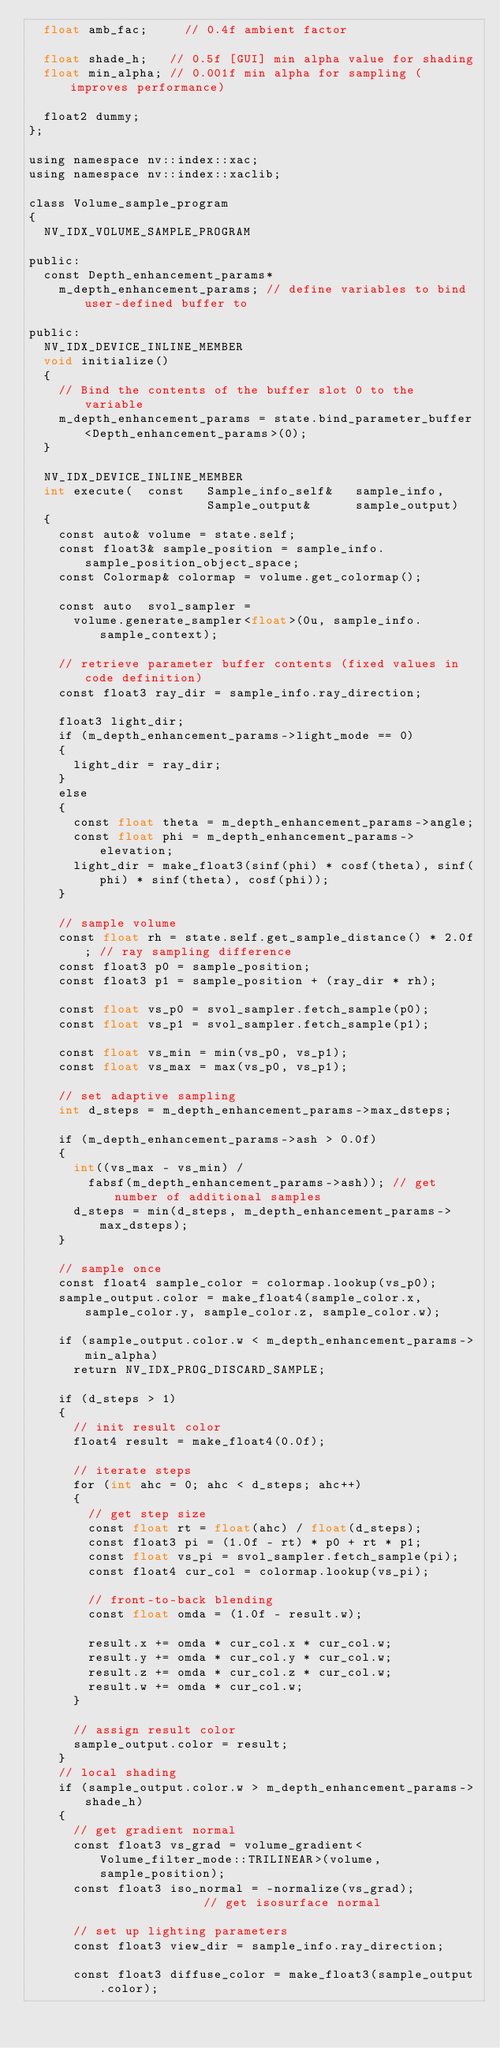Convert code to text. <code><loc_0><loc_0><loc_500><loc_500><_Cuda_>  float amb_fac;     // 0.4f ambient factor

  float shade_h;   // 0.5f [GUI] min alpha value for shading
  float min_alpha; // 0.001f min alpha for sampling (improves performance)

  float2 dummy;
};

using namespace nv::index::xac;
using namespace nv::index::xaclib;

class Volume_sample_program
{
  NV_IDX_VOLUME_SAMPLE_PROGRAM

public:
  const Depth_enhancement_params*
    m_depth_enhancement_params; // define variables to bind user-defined buffer to

public:
  NV_IDX_DEVICE_INLINE_MEMBER
  void initialize()
  {
    // Bind the contents of the buffer slot 0 to the variable
    m_depth_enhancement_params = state.bind_parameter_buffer<Depth_enhancement_params>(0);
  }

  NV_IDX_DEVICE_INLINE_MEMBER
  int execute(  const   Sample_info_self&   sample_info,
                        Sample_output&      sample_output)
  {
    const auto& volume = state.self;
    const float3& sample_position = sample_info.sample_position_object_space;
    const Colormap& colormap = volume.get_colormap();

    const auto  svol_sampler =
      volume.generate_sampler<float>(0u, sample_info.sample_context);

    // retrieve parameter buffer contents (fixed values in code definition)
    const float3 ray_dir = sample_info.ray_direction;

    float3 light_dir;
    if (m_depth_enhancement_params->light_mode == 0)
    {
      light_dir = ray_dir;
    }
    else
    {
      const float theta = m_depth_enhancement_params->angle;
      const float phi = m_depth_enhancement_params->elevation;
      light_dir = make_float3(sinf(phi) * cosf(theta), sinf(phi) * sinf(theta), cosf(phi));
    }

    // sample volume
    const float rh = state.self.get_sample_distance() * 2.0f; // ray sampling difference
    const float3 p0 = sample_position;
    const float3 p1 = sample_position + (ray_dir * rh);

    const float vs_p0 = svol_sampler.fetch_sample(p0);
    const float vs_p1 = svol_sampler.fetch_sample(p1);

    const float vs_min = min(vs_p0, vs_p1);
    const float vs_max = max(vs_p0, vs_p1);

    // set adaptive sampling
    int d_steps = m_depth_enhancement_params->max_dsteps;

    if (m_depth_enhancement_params->ash > 0.0f)
    {
      int((vs_max - vs_min) /
        fabsf(m_depth_enhancement_params->ash)); // get number of additional samples
      d_steps = min(d_steps, m_depth_enhancement_params->max_dsteps);
    }

    // sample once
    const float4 sample_color = colormap.lookup(vs_p0);
    sample_output.color = make_float4(sample_color.x, sample_color.y, sample_color.z, sample_color.w);

    if (sample_output.color.w < m_depth_enhancement_params->min_alpha)
      return NV_IDX_PROG_DISCARD_SAMPLE;

    if (d_steps > 1)
    {
      // init result color
      float4 result = make_float4(0.0f);

      // iterate steps
      for (int ahc = 0; ahc < d_steps; ahc++)
      {
        // get step size
        const float rt = float(ahc) / float(d_steps);
        const float3 pi = (1.0f - rt) * p0 + rt * p1;
        const float vs_pi = svol_sampler.fetch_sample(pi);
        const float4 cur_col = colormap.lookup(vs_pi);

        // front-to-back blending
        const float omda = (1.0f - result.w);

        result.x += omda * cur_col.x * cur_col.w;
        result.y += omda * cur_col.y * cur_col.w;
        result.z += omda * cur_col.z * cur_col.w;
        result.w += omda * cur_col.w;
      }

      // assign result color
      sample_output.color = result;
    }
    // local shading
    if (sample_output.color.w > m_depth_enhancement_params->shade_h)
    {
      // get gradient normal
      const float3 vs_grad = volume_gradient<Volume_filter_mode::TRILINEAR>(volume, sample_position);
      const float3 iso_normal = -normalize(vs_grad);               // get isosurface normal

      // set up lighting parameters
      const float3 view_dir = sample_info.ray_direction;

      const float3 diffuse_color = make_float3(sample_output.color);
</code> 